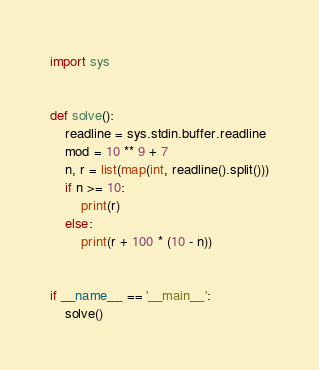<code> <loc_0><loc_0><loc_500><loc_500><_Python_>import sys


def solve():
    readline = sys.stdin.buffer.readline
    mod = 10 ** 9 + 7
    n, r = list(map(int, readline().split()))
    if n >= 10:
        print(r)
    else:
        print(r + 100 * (10 - n))


if __name__ == '__main__':
    solve()
</code> 